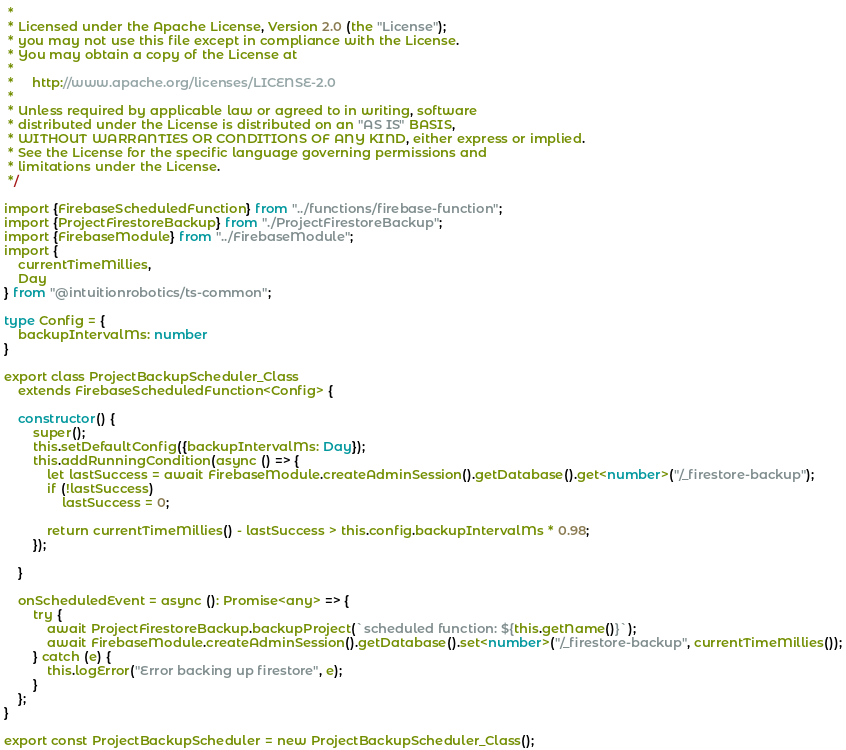Convert code to text. <code><loc_0><loc_0><loc_500><loc_500><_TypeScript_> *
 * Licensed under the Apache License, Version 2.0 (the "License");
 * you may not use this file except in compliance with the License.
 * You may obtain a copy of the License at
 *
 *     http://www.apache.org/licenses/LICENSE-2.0
 *
 * Unless required by applicable law or agreed to in writing, software
 * distributed under the License is distributed on an "AS IS" BASIS,
 * WITHOUT WARRANTIES OR CONDITIONS OF ANY KIND, either express or implied.
 * See the License for the specific language governing permissions and
 * limitations under the License.
 */

import {FirebaseScheduledFunction} from "../functions/firebase-function";
import {ProjectFirestoreBackup} from "./ProjectFirestoreBackup";
import {FirebaseModule} from "../FirebaseModule";
import {
	currentTimeMillies,
	Day
} from "@intuitionrobotics/ts-common";

type Config = {
	backupIntervalMs: number
}

export class ProjectBackupScheduler_Class
	extends FirebaseScheduledFunction<Config> {

	constructor() {
		super();
		this.setDefaultConfig({backupIntervalMs: Day});
		this.addRunningCondition(async () => {
			let lastSuccess = await FirebaseModule.createAdminSession().getDatabase().get<number>("/_firestore-backup");
			if (!lastSuccess)
				lastSuccess = 0;

			return currentTimeMillies() - lastSuccess > this.config.backupIntervalMs * 0.98;
		});

	}

	onScheduledEvent = async (): Promise<any> => {
		try {
			await ProjectFirestoreBackup.backupProject(`scheduled function: ${this.getName()}`);
			await FirebaseModule.createAdminSession().getDatabase().set<number>("/_firestore-backup", currentTimeMillies());
		} catch (e) {
			this.logError("Error backing up firestore", e);
		}
	};
}

export const ProjectBackupScheduler = new ProjectBackupScheduler_Class();
</code> 